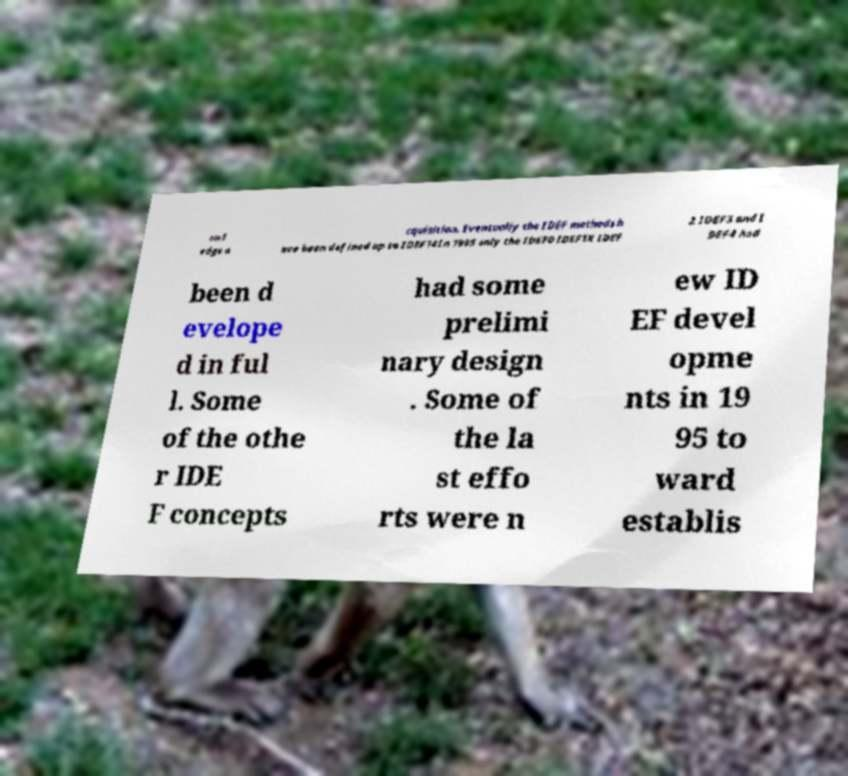For documentation purposes, I need the text within this image transcribed. Could you provide that? owl edge a cquisition. Eventually the IDEF methods h ave been defined up to IDEF14In 1995 only the IDEF0 IDEF1X IDEF 2 IDEF3 and I DEF4 had been d evelope d in ful l. Some of the othe r IDE F concepts had some prelimi nary design . Some of the la st effo rts were n ew ID EF devel opme nts in 19 95 to ward establis 